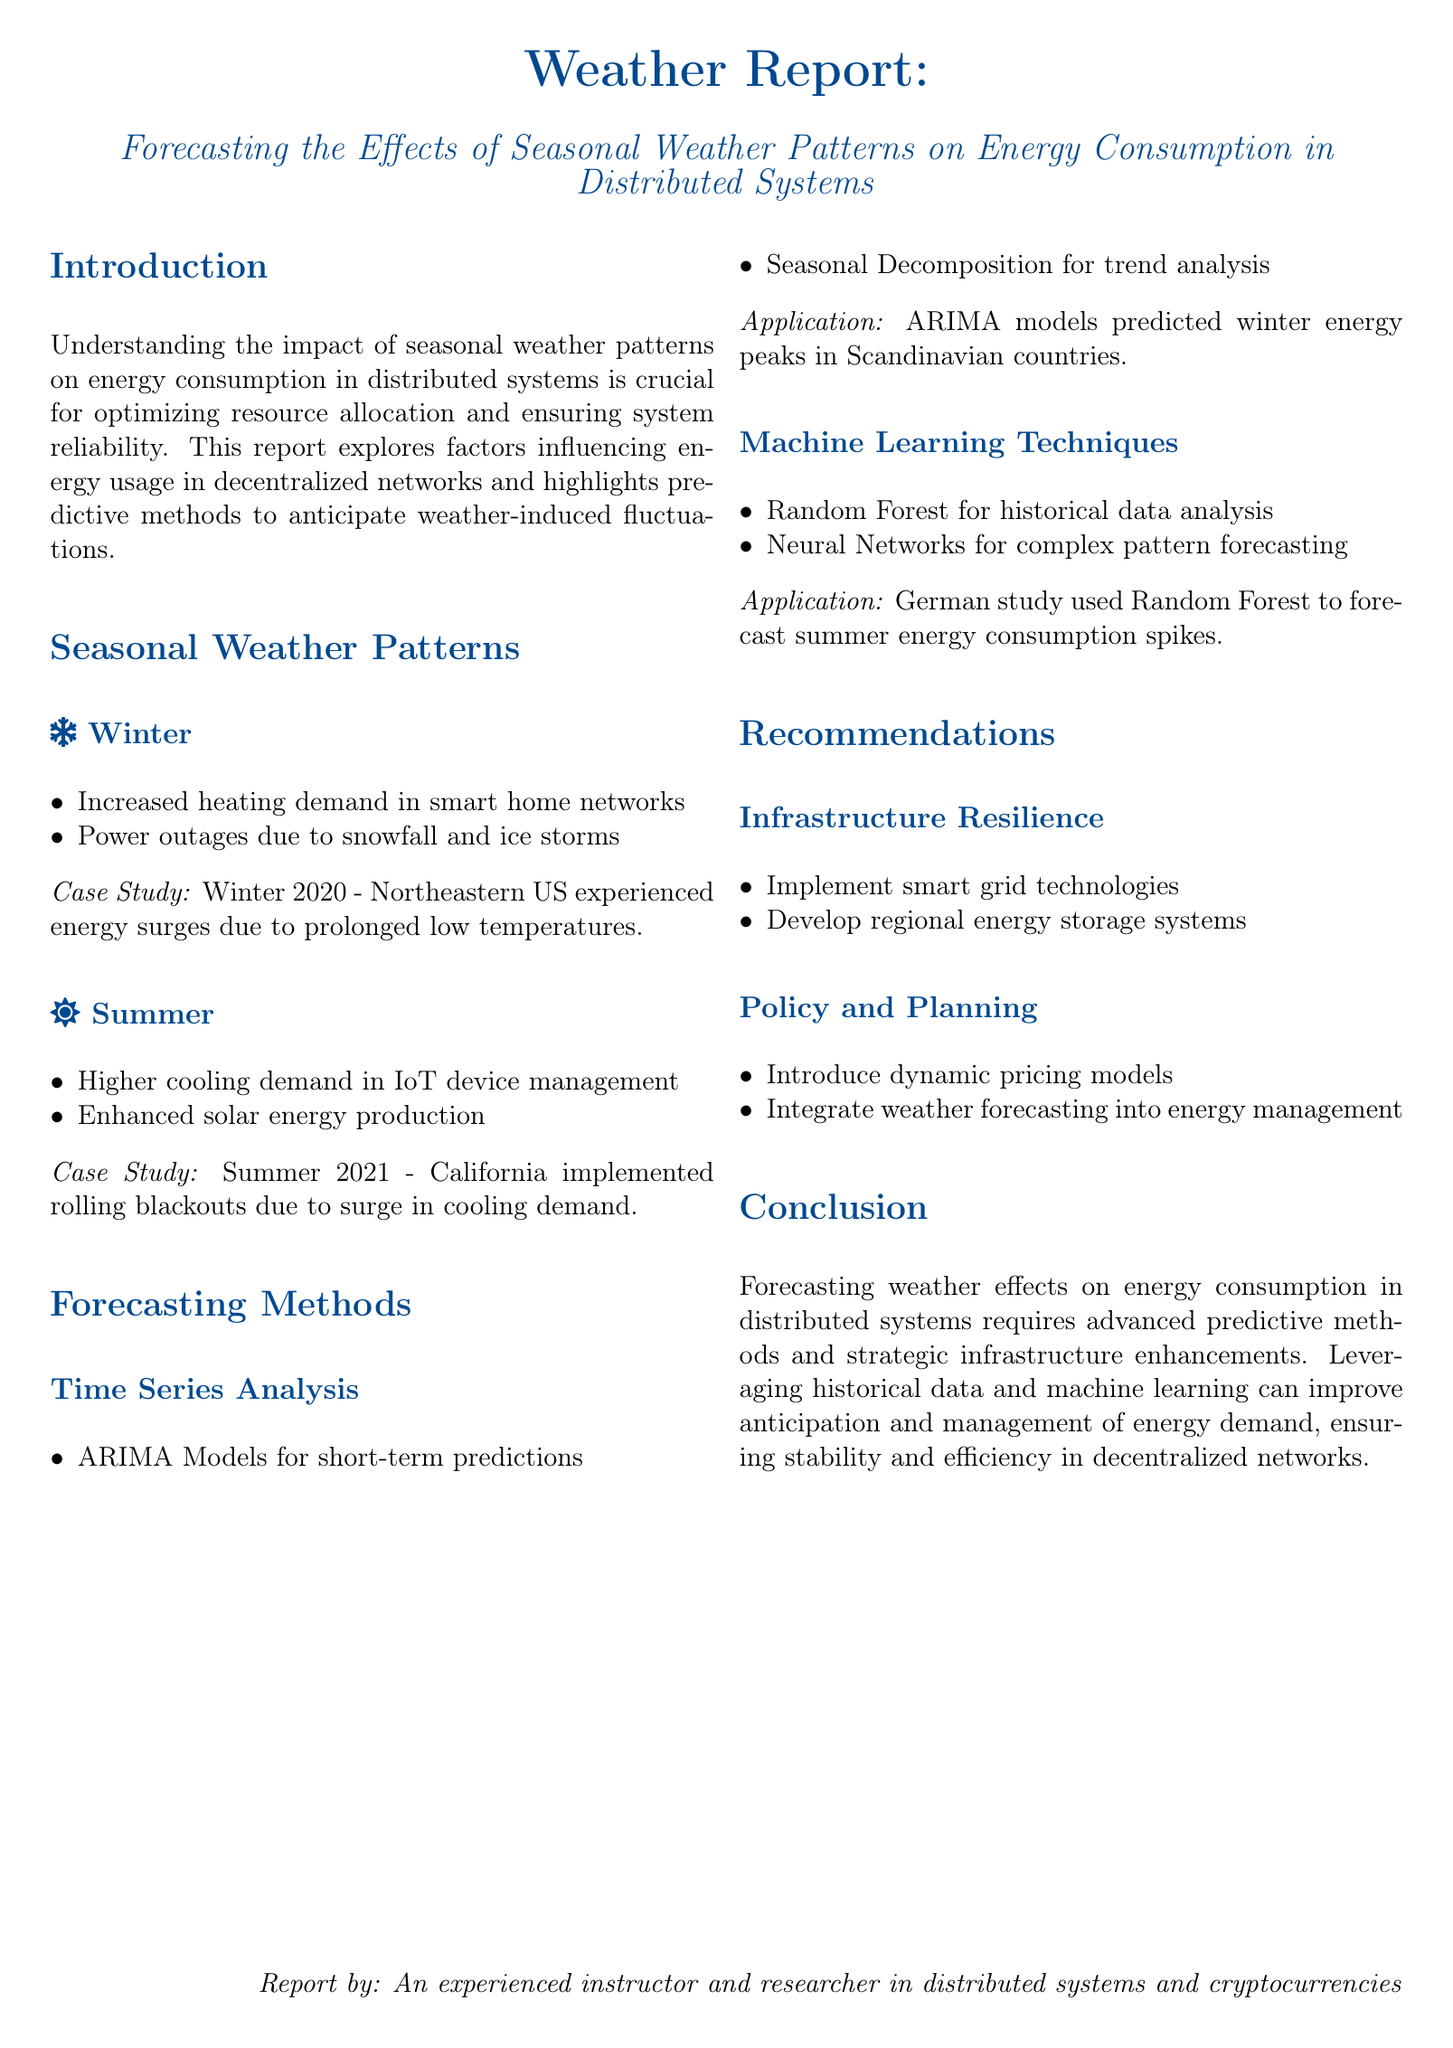What is the main focus of the report? The report emphasizes the impact of seasonal weather patterns on energy consumption in distributed systems for optimizing resource allocation and ensuring system reliability.
Answer: Seasonal weather patterns What is one method mentioned for short-term predictions? The report discusses ARIMA models as a method used for short-term predictions in energy consumption forecasting.
Answer: ARIMA Models What type of weather is associated with higher cooling demand? The document describes summer as the season that experiences higher cooling demand in IoT device management.
Answer: Summer Which event caused energy surges in January 2020 in the Northeastern US? The report indicates that prolonged low temperatures during winter in 2020 led to energy surges.
Answer: Prolonged low temperatures What organization implemented rolling blackouts in Summer 2021? According to the report, California was the state that had to implement rolling blackouts due to high cooling demand.
Answer: California What is one recommendation for enhancing infrastructure resilience? The report suggests implementing smart grid technologies as a recommendation for improving infrastructure resilience.
Answer: Smart grid technologies What predictive technique involves Random Forest? The document mentions that Random Forest can be used for historical data analysis in forecasting energy consumption.
Answer: Historical data analysis Which country's winter energy peaks were predicted using ARIMA models? The report refers to Scandinavian countries where ARIMA models were applied to predict winter energy peaks.
Answer: Scandinavian countries 